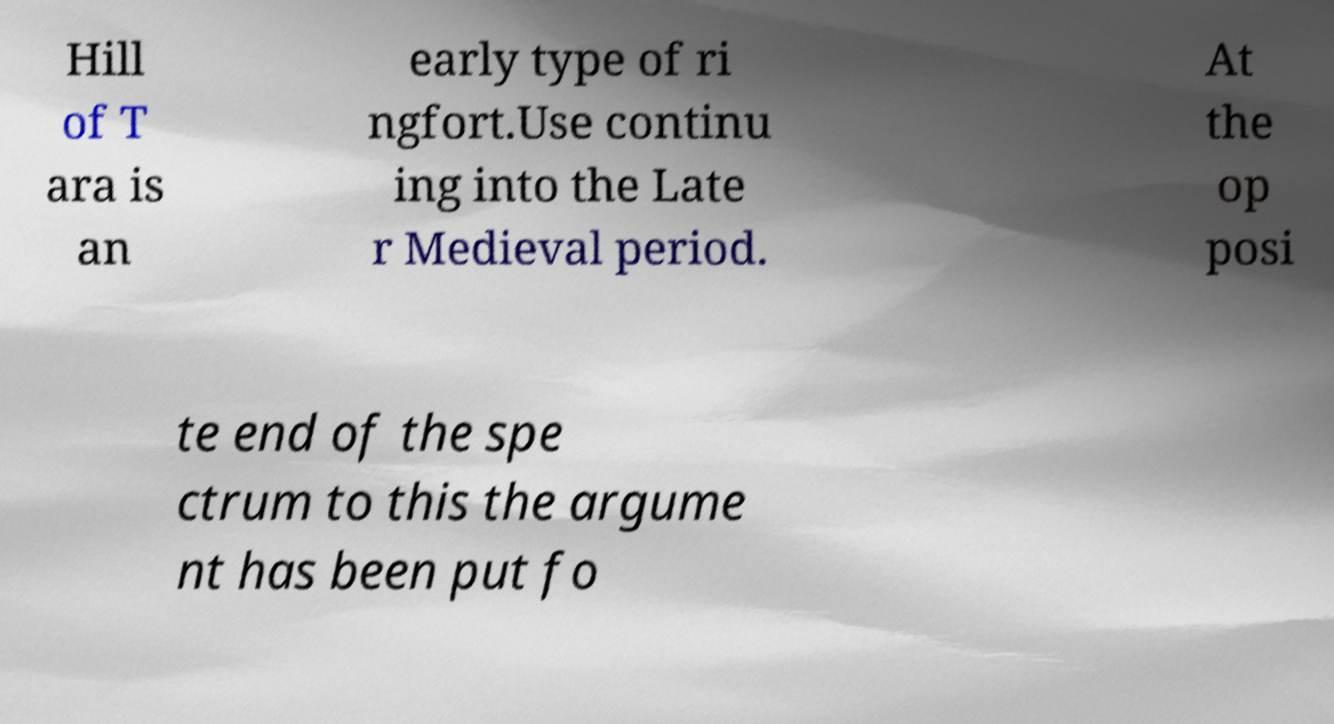Could you assist in decoding the text presented in this image and type it out clearly? Hill of T ara is an early type of ri ngfort.Use continu ing into the Late r Medieval period. At the op posi te end of the spe ctrum to this the argume nt has been put fo 